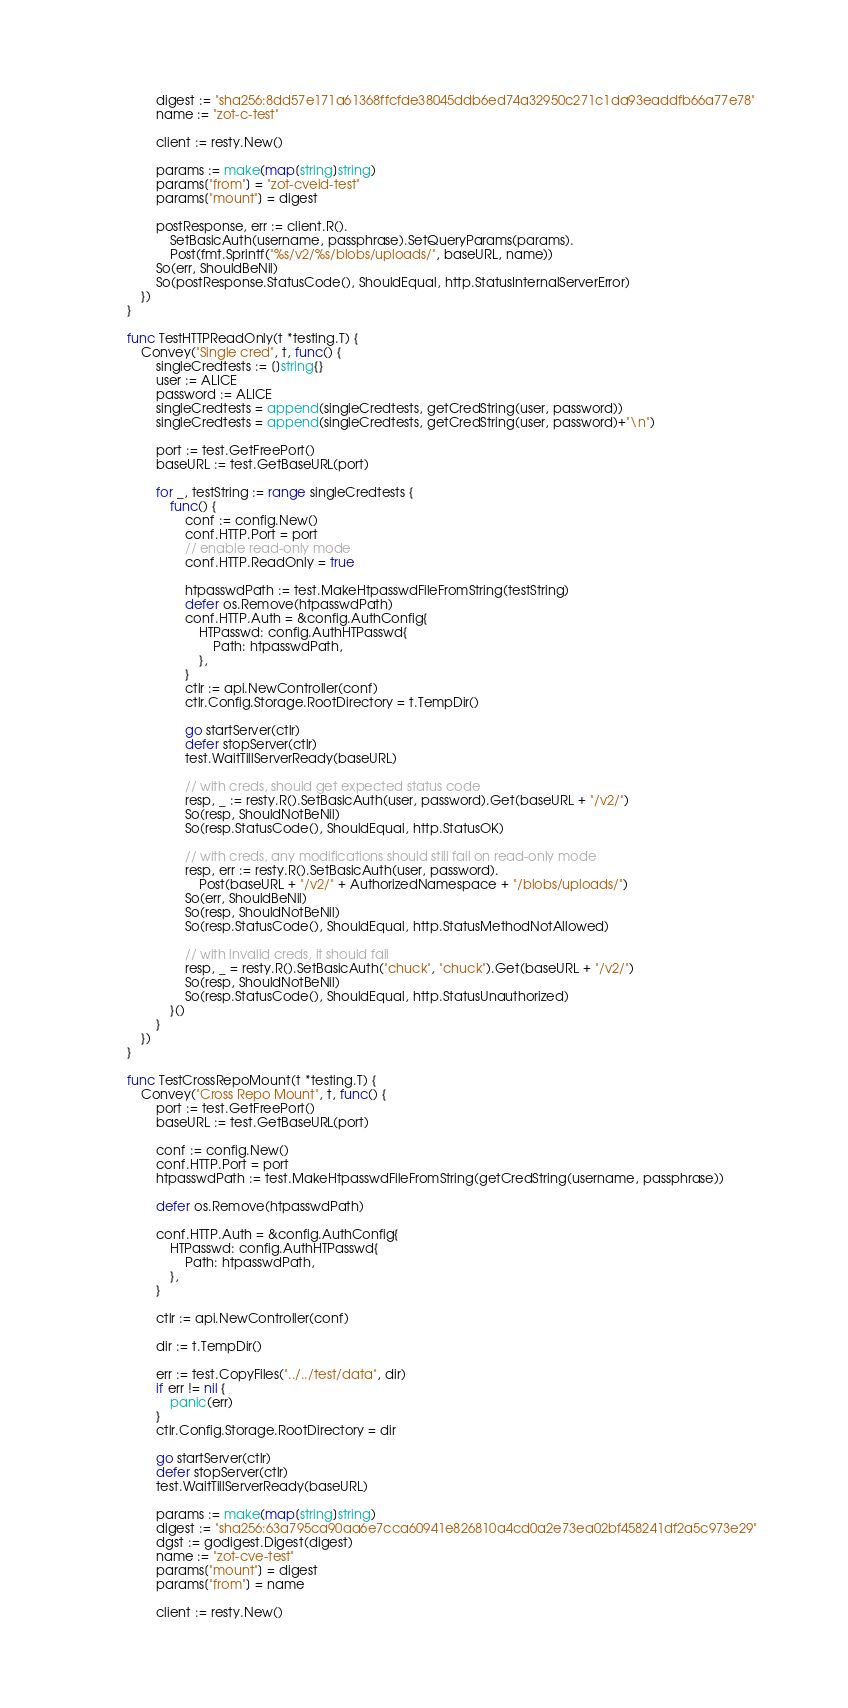Convert code to text. <code><loc_0><loc_0><loc_500><loc_500><_Go_>		digest := "sha256:8dd57e171a61368ffcfde38045ddb6ed74a32950c271c1da93eaddfb66a77e78"
		name := "zot-c-test"

		client := resty.New()

		params := make(map[string]string)
		params["from"] = "zot-cveid-test"
		params["mount"] = digest

		postResponse, err := client.R().
			SetBasicAuth(username, passphrase).SetQueryParams(params).
			Post(fmt.Sprintf("%s/v2/%s/blobs/uploads/", baseURL, name))
		So(err, ShouldBeNil)
		So(postResponse.StatusCode(), ShouldEqual, http.StatusInternalServerError)
	})
}

func TestHTTPReadOnly(t *testing.T) {
	Convey("Single cred", t, func() {
		singleCredtests := []string{}
		user := ALICE
		password := ALICE
		singleCredtests = append(singleCredtests, getCredString(user, password))
		singleCredtests = append(singleCredtests, getCredString(user, password)+"\n")

		port := test.GetFreePort()
		baseURL := test.GetBaseURL(port)

		for _, testString := range singleCredtests {
			func() {
				conf := config.New()
				conf.HTTP.Port = port
				// enable read-only mode
				conf.HTTP.ReadOnly = true

				htpasswdPath := test.MakeHtpasswdFileFromString(testString)
				defer os.Remove(htpasswdPath)
				conf.HTTP.Auth = &config.AuthConfig{
					HTPasswd: config.AuthHTPasswd{
						Path: htpasswdPath,
					},
				}
				ctlr := api.NewController(conf)
				ctlr.Config.Storage.RootDirectory = t.TempDir()

				go startServer(ctlr)
				defer stopServer(ctlr)
				test.WaitTillServerReady(baseURL)

				// with creds, should get expected status code
				resp, _ := resty.R().SetBasicAuth(user, password).Get(baseURL + "/v2/")
				So(resp, ShouldNotBeNil)
				So(resp.StatusCode(), ShouldEqual, http.StatusOK)

				// with creds, any modifications should still fail on read-only mode
				resp, err := resty.R().SetBasicAuth(user, password).
					Post(baseURL + "/v2/" + AuthorizedNamespace + "/blobs/uploads/")
				So(err, ShouldBeNil)
				So(resp, ShouldNotBeNil)
				So(resp.StatusCode(), ShouldEqual, http.StatusMethodNotAllowed)

				// with invalid creds, it should fail
				resp, _ = resty.R().SetBasicAuth("chuck", "chuck").Get(baseURL + "/v2/")
				So(resp, ShouldNotBeNil)
				So(resp.StatusCode(), ShouldEqual, http.StatusUnauthorized)
			}()
		}
	})
}

func TestCrossRepoMount(t *testing.T) {
	Convey("Cross Repo Mount", t, func() {
		port := test.GetFreePort()
		baseURL := test.GetBaseURL(port)

		conf := config.New()
		conf.HTTP.Port = port
		htpasswdPath := test.MakeHtpasswdFileFromString(getCredString(username, passphrase))

		defer os.Remove(htpasswdPath)

		conf.HTTP.Auth = &config.AuthConfig{
			HTPasswd: config.AuthHTPasswd{
				Path: htpasswdPath,
			},
		}

		ctlr := api.NewController(conf)

		dir := t.TempDir()

		err := test.CopyFiles("../../test/data", dir)
		if err != nil {
			panic(err)
		}
		ctlr.Config.Storage.RootDirectory = dir

		go startServer(ctlr)
		defer stopServer(ctlr)
		test.WaitTillServerReady(baseURL)

		params := make(map[string]string)
		digest := "sha256:63a795ca90aa6e7cca60941e826810a4cd0a2e73ea02bf458241df2a5c973e29"
		dgst := godigest.Digest(digest)
		name := "zot-cve-test"
		params["mount"] = digest
		params["from"] = name

		client := resty.New()</code> 